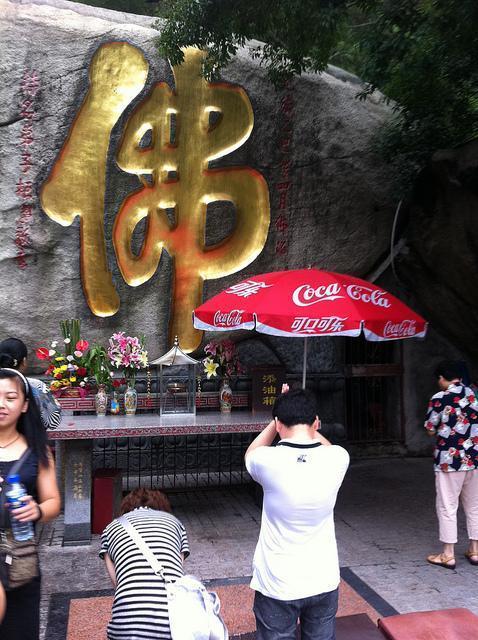How many people can you see?
Give a very brief answer. 4. How many handbags are there?
Give a very brief answer. 2. How many umbrellas are visible?
Give a very brief answer. 1. 